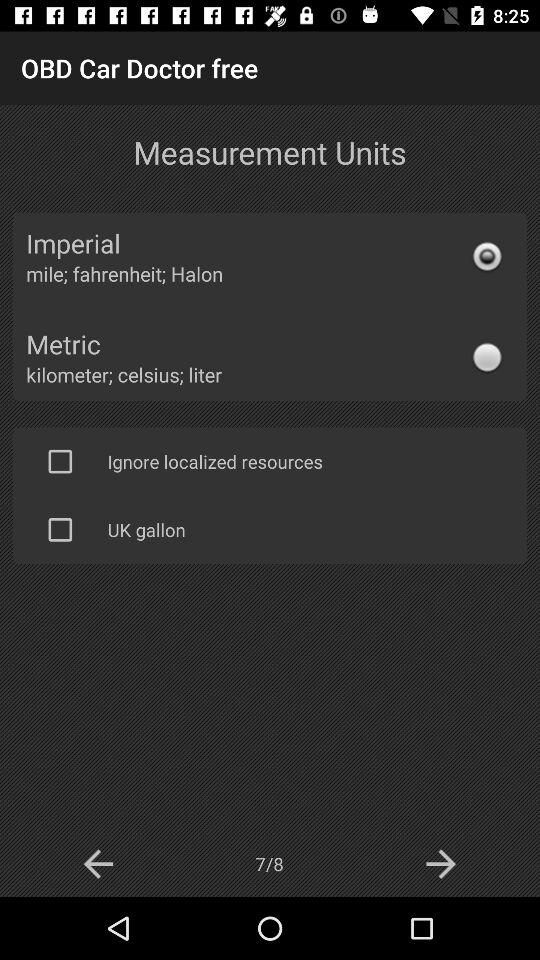Which system of measurement is selected? The selected system of measurement is "Imperial". 